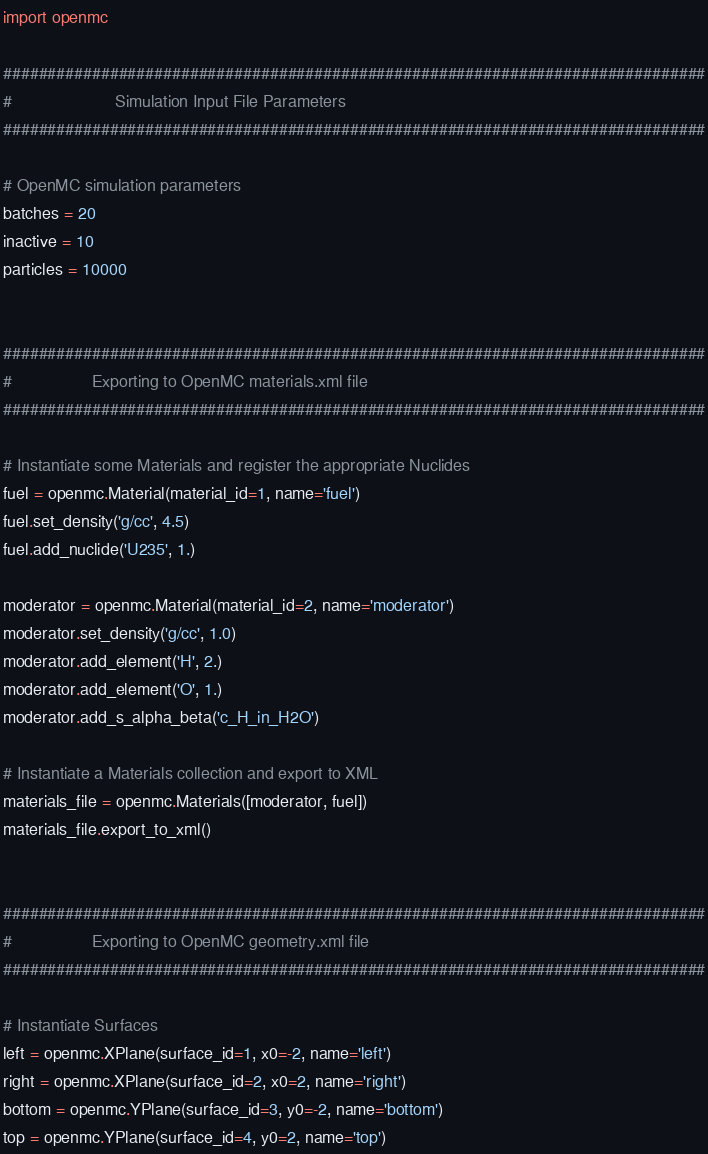<code> <loc_0><loc_0><loc_500><loc_500><_Python_>import openmc

###############################################################################
#                      Simulation Input File Parameters
###############################################################################

# OpenMC simulation parameters
batches = 20
inactive = 10
particles = 10000


###############################################################################
#                 Exporting to OpenMC materials.xml file
###############################################################################

# Instantiate some Materials and register the appropriate Nuclides
fuel = openmc.Material(material_id=1, name='fuel')
fuel.set_density('g/cc', 4.5)
fuel.add_nuclide('U235', 1.)

moderator = openmc.Material(material_id=2, name='moderator')
moderator.set_density('g/cc', 1.0)
moderator.add_element('H', 2.)
moderator.add_element('O', 1.)
moderator.add_s_alpha_beta('c_H_in_H2O')

# Instantiate a Materials collection and export to XML
materials_file = openmc.Materials([moderator, fuel])
materials_file.export_to_xml()


###############################################################################
#                 Exporting to OpenMC geometry.xml file
###############################################################################

# Instantiate Surfaces
left = openmc.XPlane(surface_id=1, x0=-2, name='left')
right = openmc.XPlane(surface_id=2, x0=2, name='right')
bottom = openmc.YPlane(surface_id=3, y0=-2, name='bottom')
top = openmc.YPlane(surface_id=4, y0=2, name='top')</code> 